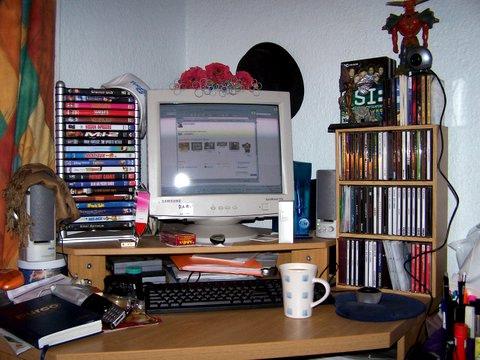Does this look items a person would bring to travel?
Short answer required. No. Where are the pencils?
Short answer required. On desk. What is in the cup?
Answer briefly. Coffee. Is the monitor new?
Write a very short answer. No. What show is on dvd?
Concise answer only. Csi. 